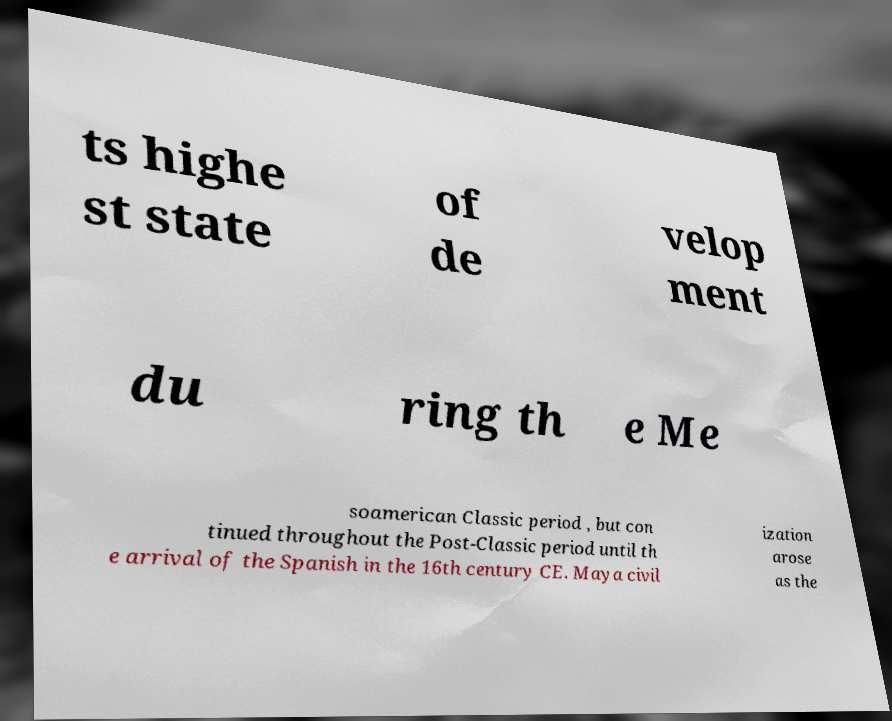What messages or text are displayed in this image? I need them in a readable, typed format. ts highe st state of de velop ment du ring th e Me soamerican Classic period , but con tinued throughout the Post-Classic period until th e arrival of the Spanish in the 16th century CE. Maya civil ization arose as the 